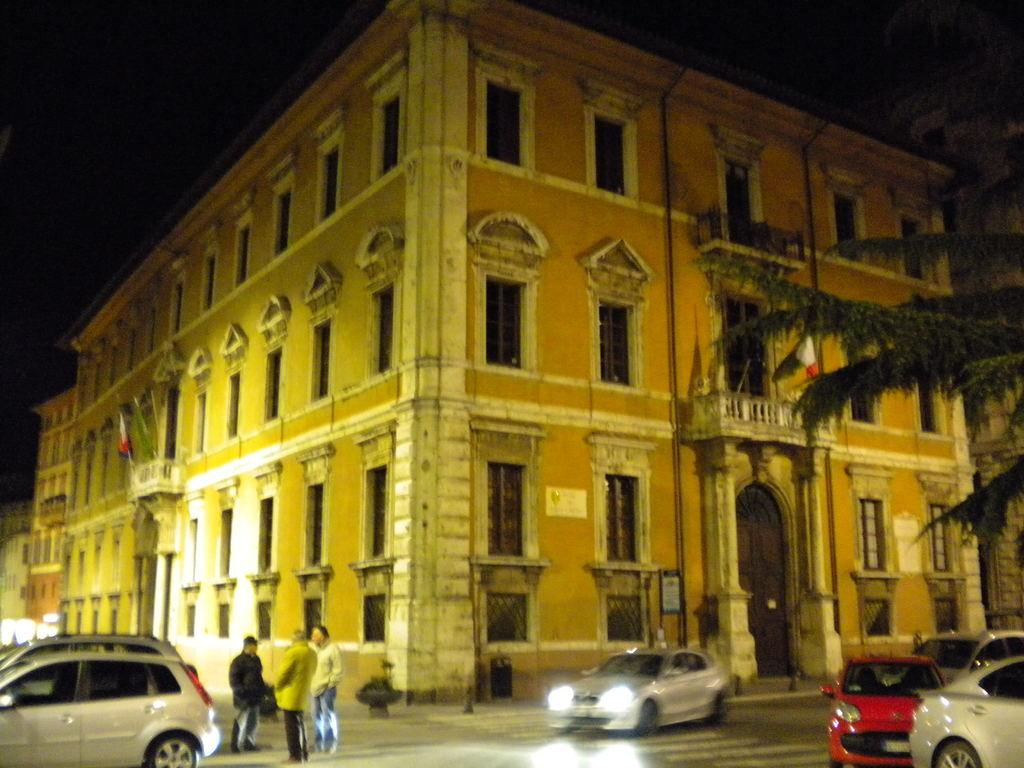What is the main subject in the center of the image? There are buildings in the center of the image. What feature do the buildings have? The buildings have windows. What can be seen flying in the image? There are flags in the image. What type of barrier is present in the image? There are fences in the image. What type of vegetation is visible in the image? There are branches with leaves in the image. What type of transportation is visible on the road in the image? There are vehicles on the road in the image. What are the people in the image doing? There are people standing in the image. What other objects can be seen in the image? There are other objects in the image. How many teeth can be seen on the girl in the image? There is no girl present in the image, and therefore no teeth can be seen. 